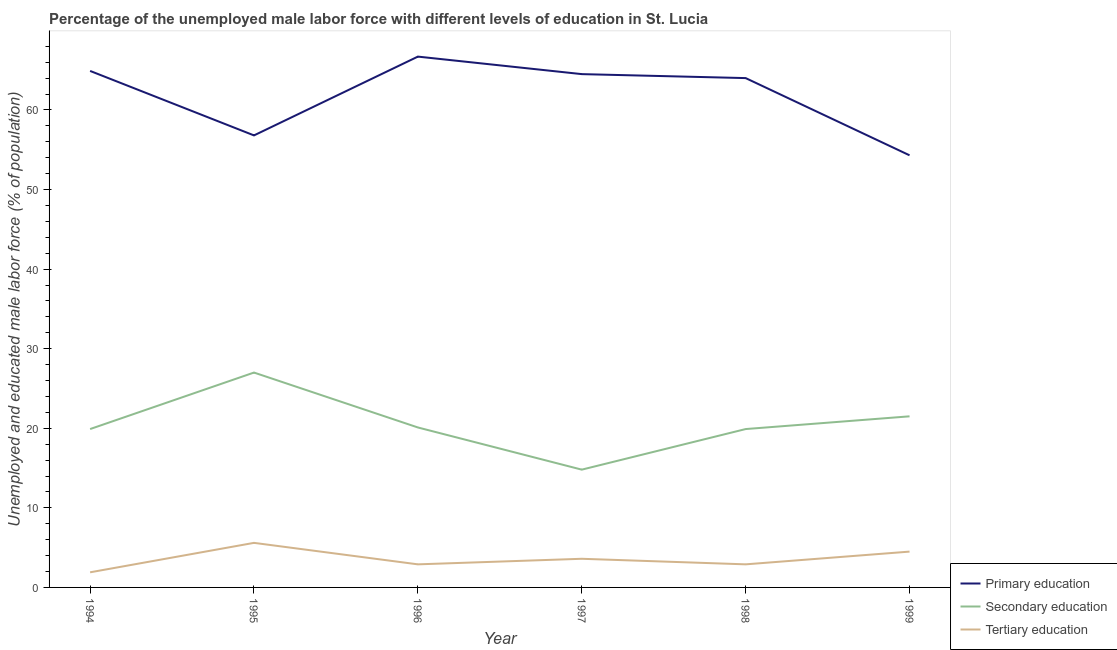Does the line corresponding to percentage of male labor force who received primary education intersect with the line corresponding to percentage of male labor force who received tertiary education?
Your response must be concise. No. What is the percentage of male labor force who received tertiary education in 1996?
Keep it short and to the point. 2.9. Across all years, what is the maximum percentage of male labor force who received primary education?
Give a very brief answer. 66.7. Across all years, what is the minimum percentage of male labor force who received secondary education?
Keep it short and to the point. 14.8. What is the total percentage of male labor force who received tertiary education in the graph?
Give a very brief answer. 21.4. What is the difference between the percentage of male labor force who received tertiary education in 1996 and that in 1999?
Provide a short and direct response. -1.6. What is the difference between the percentage of male labor force who received secondary education in 1994 and the percentage of male labor force who received primary education in 1996?
Provide a short and direct response. -46.8. What is the average percentage of male labor force who received secondary education per year?
Offer a terse response. 20.53. In the year 1994, what is the difference between the percentage of male labor force who received secondary education and percentage of male labor force who received tertiary education?
Your response must be concise. 18. What is the ratio of the percentage of male labor force who received secondary education in 1997 to that in 1998?
Ensure brevity in your answer.  0.74. Is the difference between the percentage of male labor force who received secondary education in 1996 and 1997 greater than the difference between the percentage of male labor force who received tertiary education in 1996 and 1997?
Your answer should be compact. Yes. What is the difference between the highest and the second highest percentage of male labor force who received tertiary education?
Offer a very short reply. 1.1. What is the difference between the highest and the lowest percentage of male labor force who received secondary education?
Give a very brief answer. 12.2. Does the percentage of male labor force who received tertiary education monotonically increase over the years?
Your answer should be compact. No. Is the percentage of male labor force who received tertiary education strictly less than the percentage of male labor force who received primary education over the years?
Provide a short and direct response. Yes. How many years are there in the graph?
Offer a very short reply. 6. Does the graph contain any zero values?
Your answer should be compact. No. Does the graph contain grids?
Provide a succinct answer. No. Where does the legend appear in the graph?
Your answer should be very brief. Bottom right. How are the legend labels stacked?
Make the answer very short. Vertical. What is the title of the graph?
Offer a terse response. Percentage of the unemployed male labor force with different levels of education in St. Lucia. Does "Infant(male)" appear as one of the legend labels in the graph?
Ensure brevity in your answer.  No. What is the label or title of the Y-axis?
Make the answer very short. Unemployed and educated male labor force (% of population). What is the Unemployed and educated male labor force (% of population) of Primary education in 1994?
Offer a terse response. 64.9. What is the Unemployed and educated male labor force (% of population) in Secondary education in 1994?
Offer a terse response. 19.9. What is the Unemployed and educated male labor force (% of population) in Tertiary education in 1994?
Offer a very short reply. 1.9. What is the Unemployed and educated male labor force (% of population) in Primary education in 1995?
Make the answer very short. 56.8. What is the Unemployed and educated male labor force (% of population) in Tertiary education in 1995?
Make the answer very short. 5.6. What is the Unemployed and educated male labor force (% of population) of Primary education in 1996?
Provide a short and direct response. 66.7. What is the Unemployed and educated male labor force (% of population) of Secondary education in 1996?
Make the answer very short. 20.1. What is the Unemployed and educated male labor force (% of population) in Tertiary education in 1996?
Provide a succinct answer. 2.9. What is the Unemployed and educated male labor force (% of population) in Primary education in 1997?
Keep it short and to the point. 64.5. What is the Unemployed and educated male labor force (% of population) in Secondary education in 1997?
Provide a short and direct response. 14.8. What is the Unemployed and educated male labor force (% of population) of Tertiary education in 1997?
Provide a short and direct response. 3.6. What is the Unemployed and educated male labor force (% of population) in Secondary education in 1998?
Offer a terse response. 19.9. What is the Unemployed and educated male labor force (% of population) of Tertiary education in 1998?
Make the answer very short. 2.9. What is the Unemployed and educated male labor force (% of population) in Primary education in 1999?
Your answer should be very brief. 54.3. Across all years, what is the maximum Unemployed and educated male labor force (% of population) in Primary education?
Your answer should be compact. 66.7. Across all years, what is the maximum Unemployed and educated male labor force (% of population) of Tertiary education?
Ensure brevity in your answer.  5.6. Across all years, what is the minimum Unemployed and educated male labor force (% of population) of Primary education?
Make the answer very short. 54.3. Across all years, what is the minimum Unemployed and educated male labor force (% of population) in Secondary education?
Provide a succinct answer. 14.8. Across all years, what is the minimum Unemployed and educated male labor force (% of population) in Tertiary education?
Your answer should be compact. 1.9. What is the total Unemployed and educated male labor force (% of population) of Primary education in the graph?
Offer a terse response. 371.2. What is the total Unemployed and educated male labor force (% of population) in Secondary education in the graph?
Ensure brevity in your answer.  123.2. What is the total Unemployed and educated male labor force (% of population) of Tertiary education in the graph?
Give a very brief answer. 21.4. What is the difference between the Unemployed and educated male labor force (% of population) in Primary education in 1994 and that in 1995?
Offer a very short reply. 8.1. What is the difference between the Unemployed and educated male labor force (% of population) in Tertiary education in 1994 and that in 1995?
Your answer should be very brief. -3.7. What is the difference between the Unemployed and educated male labor force (% of population) in Secondary education in 1994 and that in 1996?
Offer a very short reply. -0.2. What is the difference between the Unemployed and educated male labor force (% of population) of Tertiary education in 1994 and that in 1996?
Give a very brief answer. -1. What is the difference between the Unemployed and educated male labor force (% of population) of Primary education in 1994 and that in 1997?
Your response must be concise. 0.4. What is the difference between the Unemployed and educated male labor force (% of population) in Secondary education in 1994 and that in 1997?
Keep it short and to the point. 5.1. What is the difference between the Unemployed and educated male labor force (% of population) in Primary education in 1994 and that in 1998?
Offer a terse response. 0.9. What is the difference between the Unemployed and educated male labor force (% of population) of Secondary education in 1994 and that in 1998?
Ensure brevity in your answer.  0. What is the difference between the Unemployed and educated male labor force (% of population) in Tertiary education in 1994 and that in 1998?
Provide a succinct answer. -1. What is the difference between the Unemployed and educated male labor force (% of population) in Secondary education in 1994 and that in 1999?
Provide a short and direct response. -1.6. What is the difference between the Unemployed and educated male labor force (% of population) in Tertiary education in 1994 and that in 1999?
Keep it short and to the point. -2.6. What is the difference between the Unemployed and educated male labor force (% of population) in Primary education in 1995 and that in 1996?
Offer a very short reply. -9.9. What is the difference between the Unemployed and educated male labor force (% of population) of Secondary education in 1995 and that in 1996?
Your answer should be very brief. 6.9. What is the difference between the Unemployed and educated male labor force (% of population) in Tertiary education in 1995 and that in 1996?
Provide a short and direct response. 2.7. What is the difference between the Unemployed and educated male labor force (% of population) in Primary education in 1995 and that in 1997?
Offer a very short reply. -7.7. What is the difference between the Unemployed and educated male labor force (% of population) in Tertiary education in 1995 and that in 1997?
Offer a terse response. 2. What is the difference between the Unemployed and educated male labor force (% of population) of Primary education in 1995 and that in 1999?
Provide a short and direct response. 2.5. What is the difference between the Unemployed and educated male labor force (% of population) of Tertiary education in 1995 and that in 1999?
Your answer should be compact. 1.1. What is the difference between the Unemployed and educated male labor force (% of population) in Primary education in 1996 and that in 1997?
Offer a very short reply. 2.2. What is the difference between the Unemployed and educated male labor force (% of population) in Secondary education in 1996 and that in 1997?
Keep it short and to the point. 5.3. What is the difference between the Unemployed and educated male labor force (% of population) of Primary education in 1996 and that in 1998?
Offer a terse response. 2.7. What is the difference between the Unemployed and educated male labor force (% of population) of Secondary education in 1996 and that in 1998?
Your response must be concise. 0.2. What is the difference between the Unemployed and educated male labor force (% of population) of Primary education in 1996 and that in 1999?
Ensure brevity in your answer.  12.4. What is the difference between the Unemployed and educated male labor force (% of population) of Secondary education in 1996 and that in 1999?
Provide a short and direct response. -1.4. What is the difference between the Unemployed and educated male labor force (% of population) in Tertiary education in 1996 and that in 1999?
Your response must be concise. -1.6. What is the difference between the Unemployed and educated male labor force (% of population) of Secondary education in 1997 and that in 1998?
Make the answer very short. -5.1. What is the difference between the Unemployed and educated male labor force (% of population) in Tertiary education in 1997 and that in 1998?
Ensure brevity in your answer.  0.7. What is the difference between the Unemployed and educated male labor force (% of population) of Primary education in 1997 and that in 1999?
Make the answer very short. 10.2. What is the difference between the Unemployed and educated male labor force (% of population) of Secondary education in 1997 and that in 1999?
Offer a terse response. -6.7. What is the difference between the Unemployed and educated male labor force (% of population) of Tertiary education in 1997 and that in 1999?
Make the answer very short. -0.9. What is the difference between the Unemployed and educated male labor force (% of population) in Secondary education in 1998 and that in 1999?
Provide a succinct answer. -1.6. What is the difference between the Unemployed and educated male labor force (% of population) in Tertiary education in 1998 and that in 1999?
Ensure brevity in your answer.  -1.6. What is the difference between the Unemployed and educated male labor force (% of population) of Primary education in 1994 and the Unemployed and educated male labor force (% of population) of Secondary education in 1995?
Offer a very short reply. 37.9. What is the difference between the Unemployed and educated male labor force (% of population) of Primary education in 1994 and the Unemployed and educated male labor force (% of population) of Tertiary education in 1995?
Provide a short and direct response. 59.3. What is the difference between the Unemployed and educated male labor force (% of population) of Primary education in 1994 and the Unemployed and educated male labor force (% of population) of Secondary education in 1996?
Provide a short and direct response. 44.8. What is the difference between the Unemployed and educated male labor force (% of population) in Secondary education in 1994 and the Unemployed and educated male labor force (% of population) in Tertiary education in 1996?
Provide a succinct answer. 17. What is the difference between the Unemployed and educated male labor force (% of population) in Primary education in 1994 and the Unemployed and educated male labor force (% of population) in Secondary education in 1997?
Offer a very short reply. 50.1. What is the difference between the Unemployed and educated male labor force (% of population) of Primary education in 1994 and the Unemployed and educated male labor force (% of population) of Tertiary education in 1997?
Your answer should be very brief. 61.3. What is the difference between the Unemployed and educated male labor force (% of population) in Secondary education in 1994 and the Unemployed and educated male labor force (% of population) in Tertiary education in 1997?
Give a very brief answer. 16.3. What is the difference between the Unemployed and educated male labor force (% of population) of Primary education in 1994 and the Unemployed and educated male labor force (% of population) of Tertiary education in 1998?
Ensure brevity in your answer.  62. What is the difference between the Unemployed and educated male labor force (% of population) in Primary education in 1994 and the Unemployed and educated male labor force (% of population) in Secondary education in 1999?
Your response must be concise. 43.4. What is the difference between the Unemployed and educated male labor force (% of population) in Primary education in 1994 and the Unemployed and educated male labor force (% of population) in Tertiary education in 1999?
Ensure brevity in your answer.  60.4. What is the difference between the Unemployed and educated male labor force (% of population) in Secondary education in 1994 and the Unemployed and educated male labor force (% of population) in Tertiary education in 1999?
Your answer should be very brief. 15.4. What is the difference between the Unemployed and educated male labor force (% of population) of Primary education in 1995 and the Unemployed and educated male labor force (% of population) of Secondary education in 1996?
Provide a short and direct response. 36.7. What is the difference between the Unemployed and educated male labor force (% of population) in Primary education in 1995 and the Unemployed and educated male labor force (% of population) in Tertiary education in 1996?
Ensure brevity in your answer.  53.9. What is the difference between the Unemployed and educated male labor force (% of population) in Secondary education in 1995 and the Unemployed and educated male labor force (% of population) in Tertiary education in 1996?
Your response must be concise. 24.1. What is the difference between the Unemployed and educated male labor force (% of population) in Primary education in 1995 and the Unemployed and educated male labor force (% of population) in Secondary education in 1997?
Give a very brief answer. 42. What is the difference between the Unemployed and educated male labor force (% of population) of Primary education in 1995 and the Unemployed and educated male labor force (% of population) of Tertiary education in 1997?
Provide a short and direct response. 53.2. What is the difference between the Unemployed and educated male labor force (% of population) in Secondary education in 1995 and the Unemployed and educated male labor force (% of population) in Tertiary education in 1997?
Provide a short and direct response. 23.4. What is the difference between the Unemployed and educated male labor force (% of population) of Primary education in 1995 and the Unemployed and educated male labor force (% of population) of Secondary education in 1998?
Give a very brief answer. 36.9. What is the difference between the Unemployed and educated male labor force (% of population) in Primary education in 1995 and the Unemployed and educated male labor force (% of population) in Tertiary education in 1998?
Provide a succinct answer. 53.9. What is the difference between the Unemployed and educated male labor force (% of population) of Secondary education in 1995 and the Unemployed and educated male labor force (% of population) of Tertiary education in 1998?
Ensure brevity in your answer.  24.1. What is the difference between the Unemployed and educated male labor force (% of population) in Primary education in 1995 and the Unemployed and educated male labor force (% of population) in Secondary education in 1999?
Provide a short and direct response. 35.3. What is the difference between the Unemployed and educated male labor force (% of population) in Primary education in 1995 and the Unemployed and educated male labor force (% of population) in Tertiary education in 1999?
Your answer should be compact. 52.3. What is the difference between the Unemployed and educated male labor force (% of population) in Secondary education in 1995 and the Unemployed and educated male labor force (% of population) in Tertiary education in 1999?
Offer a very short reply. 22.5. What is the difference between the Unemployed and educated male labor force (% of population) in Primary education in 1996 and the Unemployed and educated male labor force (% of population) in Secondary education in 1997?
Provide a succinct answer. 51.9. What is the difference between the Unemployed and educated male labor force (% of population) in Primary education in 1996 and the Unemployed and educated male labor force (% of population) in Tertiary education in 1997?
Ensure brevity in your answer.  63.1. What is the difference between the Unemployed and educated male labor force (% of population) in Secondary education in 1996 and the Unemployed and educated male labor force (% of population) in Tertiary education in 1997?
Offer a terse response. 16.5. What is the difference between the Unemployed and educated male labor force (% of population) of Primary education in 1996 and the Unemployed and educated male labor force (% of population) of Secondary education in 1998?
Your answer should be very brief. 46.8. What is the difference between the Unemployed and educated male labor force (% of population) of Primary education in 1996 and the Unemployed and educated male labor force (% of population) of Tertiary education in 1998?
Give a very brief answer. 63.8. What is the difference between the Unemployed and educated male labor force (% of population) in Primary education in 1996 and the Unemployed and educated male labor force (% of population) in Secondary education in 1999?
Make the answer very short. 45.2. What is the difference between the Unemployed and educated male labor force (% of population) of Primary education in 1996 and the Unemployed and educated male labor force (% of population) of Tertiary education in 1999?
Offer a very short reply. 62.2. What is the difference between the Unemployed and educated male labor force (% of population) of Primary education in 1997 and the Unemployed and educated male labor force (% of population) of Secondary education in 1998?
Your response must be concise. 44.6. What is the difference between the Unemployed and educated male labor force (% of population) of Primary education in 1997 and the Unemployed and educated male labor force (% of population) of Tertiary education in 1998?
Offer a very short reply. 61.6. What is the difference between the Unemployed and educated male labor force (% of population) in Primary education in 1997 and the Unemployed and educated male labor force (% of population) in Tertiary education in 1999?
Offer a terse response. 60. What is the difference between the Unemployed and educated male labor force (% of population) in Secondary education in 1997 and the Unemployed and educated male labor force (% of population) in Tertiary education in 1999?
Offer a terse response. 10.3. What is the difference between the Unemployed and educated male labor force (% of population) of Primary education in 1998 and the Unemployed and educated male labor force (% of population) of Secondary education in 1999?
Your response must be concise. 42.5. What is the difference between the Unemployed and educated male labor force (% of population) in Primary education in 1998 and the Unemployed and educated male labor force (% of population) in Tertiary education in 1999?
Make the answer very short. 59.5. What is the difference between the Unemployed and educated male labor force (% of population) in Secondary education in 1998 and the Unemployed and educated male labor force (% of population) in Tertiary education in 1999?
Your answer should be compact. 15.4. What is the average Unemployed and educated male labor force (% of population) of Primary education per year?
Your response must be concise. 61.87. What is the average Unemployed and educated male labor force (% of population) of Secondary education per year?
Keep it short and to the point. 20.53. What is the average Unemployed and educated male labor force (% of population) in Tertiary education per year?
Provide a short and direct response. 3.57. In the year 1994, what is the difference between the Unemployed and educated male labor force (% of population) in Secondary education and Unemployed and educated male labor force (% of population) in Tertiary education?
Your answer should be compact. 18. In the year 1995, what is the difference between the Unemployed and educated male labor force (% of population) in Primary education and Unemployed and educated male labor force (% of population) in Secondary education?
Make the answer very short. 29.8. In the year 1995, what is the difference between the Unemployed and educated male labor force (% of population) in Primary education and Unemployed and educated male labor force (% of population) in Tertiary education?
Your answer should be very brief. 51.2. In the year 1995, what is the difference between the Unemployed and educated male labor force (% of population) in Secondary education and Unemployed and educated male labor force (% of population) in Tertiary education?
Ensure brevity in your answer.  21.4. In the year 1996, what is the difference between the Unemployed and educated male labor force (% of population) of Primary education and Unemployed and educated male labor force (% of population) of Secondary education?
Make the answer very short. 46.6. In the year 1996, what is the difference between the Unemployed and educated male labor force (% of population) in Primary education and Unemployed and educated male labor force (% of population) in Tertiary education?
Provide a short and direct response. 63.8. In the year 1996, what is the difference between the Unemployed and educated male labor force (% of population) of Secondary education and Unemployed and educated male labor force (% of population) of Tertiary education?
Keep it short and to the point. 17.2. In the year 1997, what is the difference between the Unemployed and educated male labor force (% of population) in Primary education and Unemployed and educated male labor force (% of population) in Secondary education?
Provide a short and direct response. 49.7. In the year 1997, what is the difference between the Unemployed and educated male labor force (% of population) of Primary education and Unemployed and educated male labor force (% of population) of Tertiary education?
Your answer should be compact. 60.9. In the year 1998, what is the difference between the Unemployed and educated male labor force (% of population) in Primary education and Unemployed and educated male labor force (% of population) in Secondary education?
Provide a succinct answer. 44.1. In the year 1998, what is the difference between the Unemployed and educated male labor force (% of population) of Primary education and Unemployed and educated male labor force (% of population) of Tertiary education?
Your answer should be very brief. 61.1. In the year 1999, what is the difference between the Unemployed and educated male labor force (% of population) of Primary education and Unemployed and educated male labor force (% of population) of Secondary education?
Provide a succinct answer. 32.8. In the year 1999, what is the difference between the Unemployed and educated male labor force (% of population) of Primary education and Unemployed and educated male labor force (% of population) of Tertiary education?
Keep it short and to the point. 49.8. What is the ratio of the Unemployed and educated male labor force (% of population) of Primary education in 1994 to that in 1995?
Your answer should be very brief. 1.14. What is the ratio of the Unemployed and educated male labor force (% of population) in Secondary education in 1994 to that in 1995?
Provide a short and direct response. 0.74. What is the ratio of the Unemployed and educated male labor force (% of population) of Tertiary education in 1994 to that in 1995?
Your answer should be compact. 0.34. What is the ratio of the Unemployed and educated male labor force (% of population) of Primary education in 1994 to that in 1996?
Offer a terse response. 0.97. What is the ratio of the Unemployed and educated male labor force (% of population) of Tertiary education in 1994 to that in 1996?
Make the answer very short. 0.66. What is the ratio of the Unemployed and educated male labor force (% of population) in Secondary education in 1994 to that in 1997?
Your response must be concise. 1.34. What is the ratio of the Unemployed and educated male labor force (% of population) in Tertiary education in 1994 to that in 1997?
Your answer should be compact. 0.53. What is the ratio of the Unemployed and educated male labor force (% of population) in Primary education in 1994 to that in 1998?
Your answer should be very brief. 1.01. What is the ratio of the Unemployed and educated male labor force (% of population) of Secondary education in 1994 to that in 1998?
Make the answer very short. 1. What is the ratio of the Unemployed and educated male labor force (% of population) of Tertiary education in 1994 to that in 1998?
Your answer should be compact. 0.66. What is the ratio of the Unemployed and educated male labor force (% of population) of Primary education in 1994 to that in 1999?
Make the answer very short. 1.2. What is the ratio of the Unemployed and educated male labor force (% of population) of Secondary education in 1994 to that in 1999?
Give a very brief answer. 0.93. What is the ratio of the Unemployed and educated male labor force (% of population) of Tertiary education in 1994 to that in 1999?
Keep it short and to the point. 0.42. What is the ratio of the Unemployed and educated male labor force (% of population) of Primary education in 1995 to that in 1996?
Offer a very short reply. 0.85. What is the ratio of the Unemployed and educated male labor force (% of population) in Secondary education in 1995 to that in 1996?
Ensure brevity in your answer.  1.34. What is the ratio of the Unemployed and educated male labor force (% of population) in Tertiary education in 1995 to that in 1996?
Provide a short and direct response. 1.93. What is the ratio of the Unemployed and educated male labor force (% of population) of Primary education in 1995 to that in 1997?
Offer a very short reply. 0.88. What is the ratio of the Unemployed and educated male labor force (% of population) in Secondary education in 1995 to that in 1997?
Offer a terse response. 1.82. What is the ratio of the Unemployed and educated male labor force (% of population) of Tertiary education in 1995 to that in 1997?
Ensure brevity in your answer.  1.56. What is the ratio of the Unemployed and educated male labor force (% of population) in Primary education in 1995 to that in 1998?
Provide a succinct answer. 0.89. What is the ratio of the Unemployed and educated male labor force (% of population) of Secondary education in 1995 to that in 1998?
Make the answer very short. 1.36. What is the ratio of the Unemployed and educated male labor force (% of population) of Tertiary education in 1995 to that in 1998?
Give a very brief answer. 1.93. What is the ratio of the Unemployed and educated male labor force (% of population) of Primary education in 1995 to that in 1999?
Make the answer very short. 1.05. What is the ratio of the Unemployed and educated male labor force (% of population) of Secondary education in 1995 to that in 1999?
Your answer should be very brief. 1.26. What is the ratio of the Unemployed and educated male labor force (% of population) of Tertiary education in 1995 to that in 1999?
Your answer should be very brief. 1.24. What is the ratio of the Unemployed and educated male labor force (% of population) of Primary education in 1996 to that in 1997?
Your response must be concise. 1.03. What is the ratio of the Unemployed and educated male labor force (% of population) of Secondary education in 1996 to that in 1997?
Offer a very short reply. 1.36. What is the ratio of the Unemployed and educated male labor force (% of population) of Tertiary education in 1996 to that in 1997?
Your answer should be very brief. 0.81. What is the ratio of the Unemployed and educated male labor force (% of population) in Primary education in 1996 to that in 1998?
Offer a very short reply. 1.04. What is the ratio of the Unemployed and educated male labor force (% of population) of Secondary education in 1996 to that in 1998?
Offer a very short reply. 1.01. What is the ratio of the Unemployed and educated male labor force (% of population) of Primary education in 1996 to that in 1999?
Your response must be concise. 1.23. What is the ratio of the Unemployed and educated male labor force (% of population) of Secondary education in 1996 to that in 1999?
Give a very brief answer. 0.93. What is the ratio of the Unemployed and educated male labor force (% of population) of Tertiary education in 1996 to that in 1999?
Ensure brevity in your answer.  0.64. What is the ratio of the Unemployed and educated male labor force (% of population) in Primary education in 1997 to that in 1998?
Make the answer very short. 1.01. What is the ratio of the Unemployed and educated male labor force (% of population) of Secondary education in 1997 to that in 1998?
Your answer should be very brief. 0.74. What is the ratio of the Unemployed and educated male labor force (% of population) of Tertiary education in 1997 to that in 1998?
Make the answer very short. 1.24. What is the ratio of the Unemployed and educated male labor force (% of population) of Primary education in 1997 to that in 1999?
Keep it short and to the point. 1.19. What is the ratio of the Unemployed and educated male labor force (% of population) of Secondary education in 1997 to that in 1999?
Offer a very short reply. 0.69. What is the ratio of the Unemployed and educated male labor force (% of population) in Tertiary education in 1997 to that in 1999?
Provide a short and direct response. 0.8. What is the ratio of the Unemployed and educated male labor force (% of population) in Primary education in 1998 to that in 1999?
Ensure brevity in your answer.  1.18. What is the ratio of the Unemployed and educated male labor force (% of population) of Secondary education in 1998 to that in 1999?
Offer a terse response. 0.93. What is the ratio of the Unemployed and educated male labor force (% of population) of Tertiary education in 1998 to that in 1999?
Provide a short and direct response. 0.64. What is the difference between the highest and the second highest Unemployed and educated male labor force (% of population) of Primary education?
Give a very brief answer. 1.8. What is the difference between the highest and the second highest Unemployed and educated male labor force (% of population) of Secondary education?
Keep it short and to the point. 5.5. What is the difference between the highest and the lowest Unemployed and educated male labor force (% of population) in Secondary education?
Offer a terse response. 12.2. What is the difference between the highest and the lowest Unemployed and educated male labor force (% of population) in Tertiary education?
Provide a succinct answer. 3.7. 